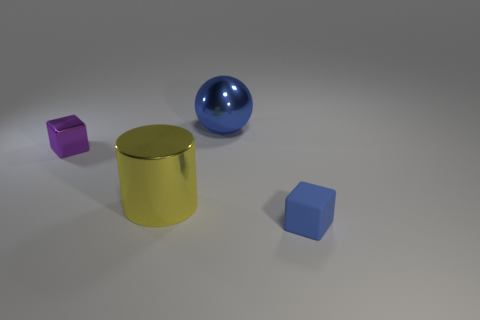Is the number of blocks that are left of the metallic block the same as the number of purple cubes that are behind the small blue object?
Your answer should be compact. No. There is a object that is to the right of the shiny ball; what is its size?
Offer a terse response. Small. Does the ball have the same color as the tiny matte object?
Provide a short and direct response. Yes. Is there any other thing that has the same shape as the matte object?
Provide a succinct answer. Yes. There is a big ball that is the same color as the rubber object; what is it made of?
Keep it short and to the point. Metal. Is the number of metal spheres that are in front of the blue block the same as the number of small purple spheres?
Your response must be concise. Yes. There is a tiny blue object; are there any blue rubber blocks behind it?
Give a very brief answer. No. There is a big yellow thing; is it the same shape as the blue thing in front of the blue metal sphere?
Keep it short and to the point. No. There is a sphere that is made of the same material as the big yellow cylinder; what is its color?
Give a very brief answer. Blue. What color is the large cylinder?
Offer a very short reply. Yellow. 